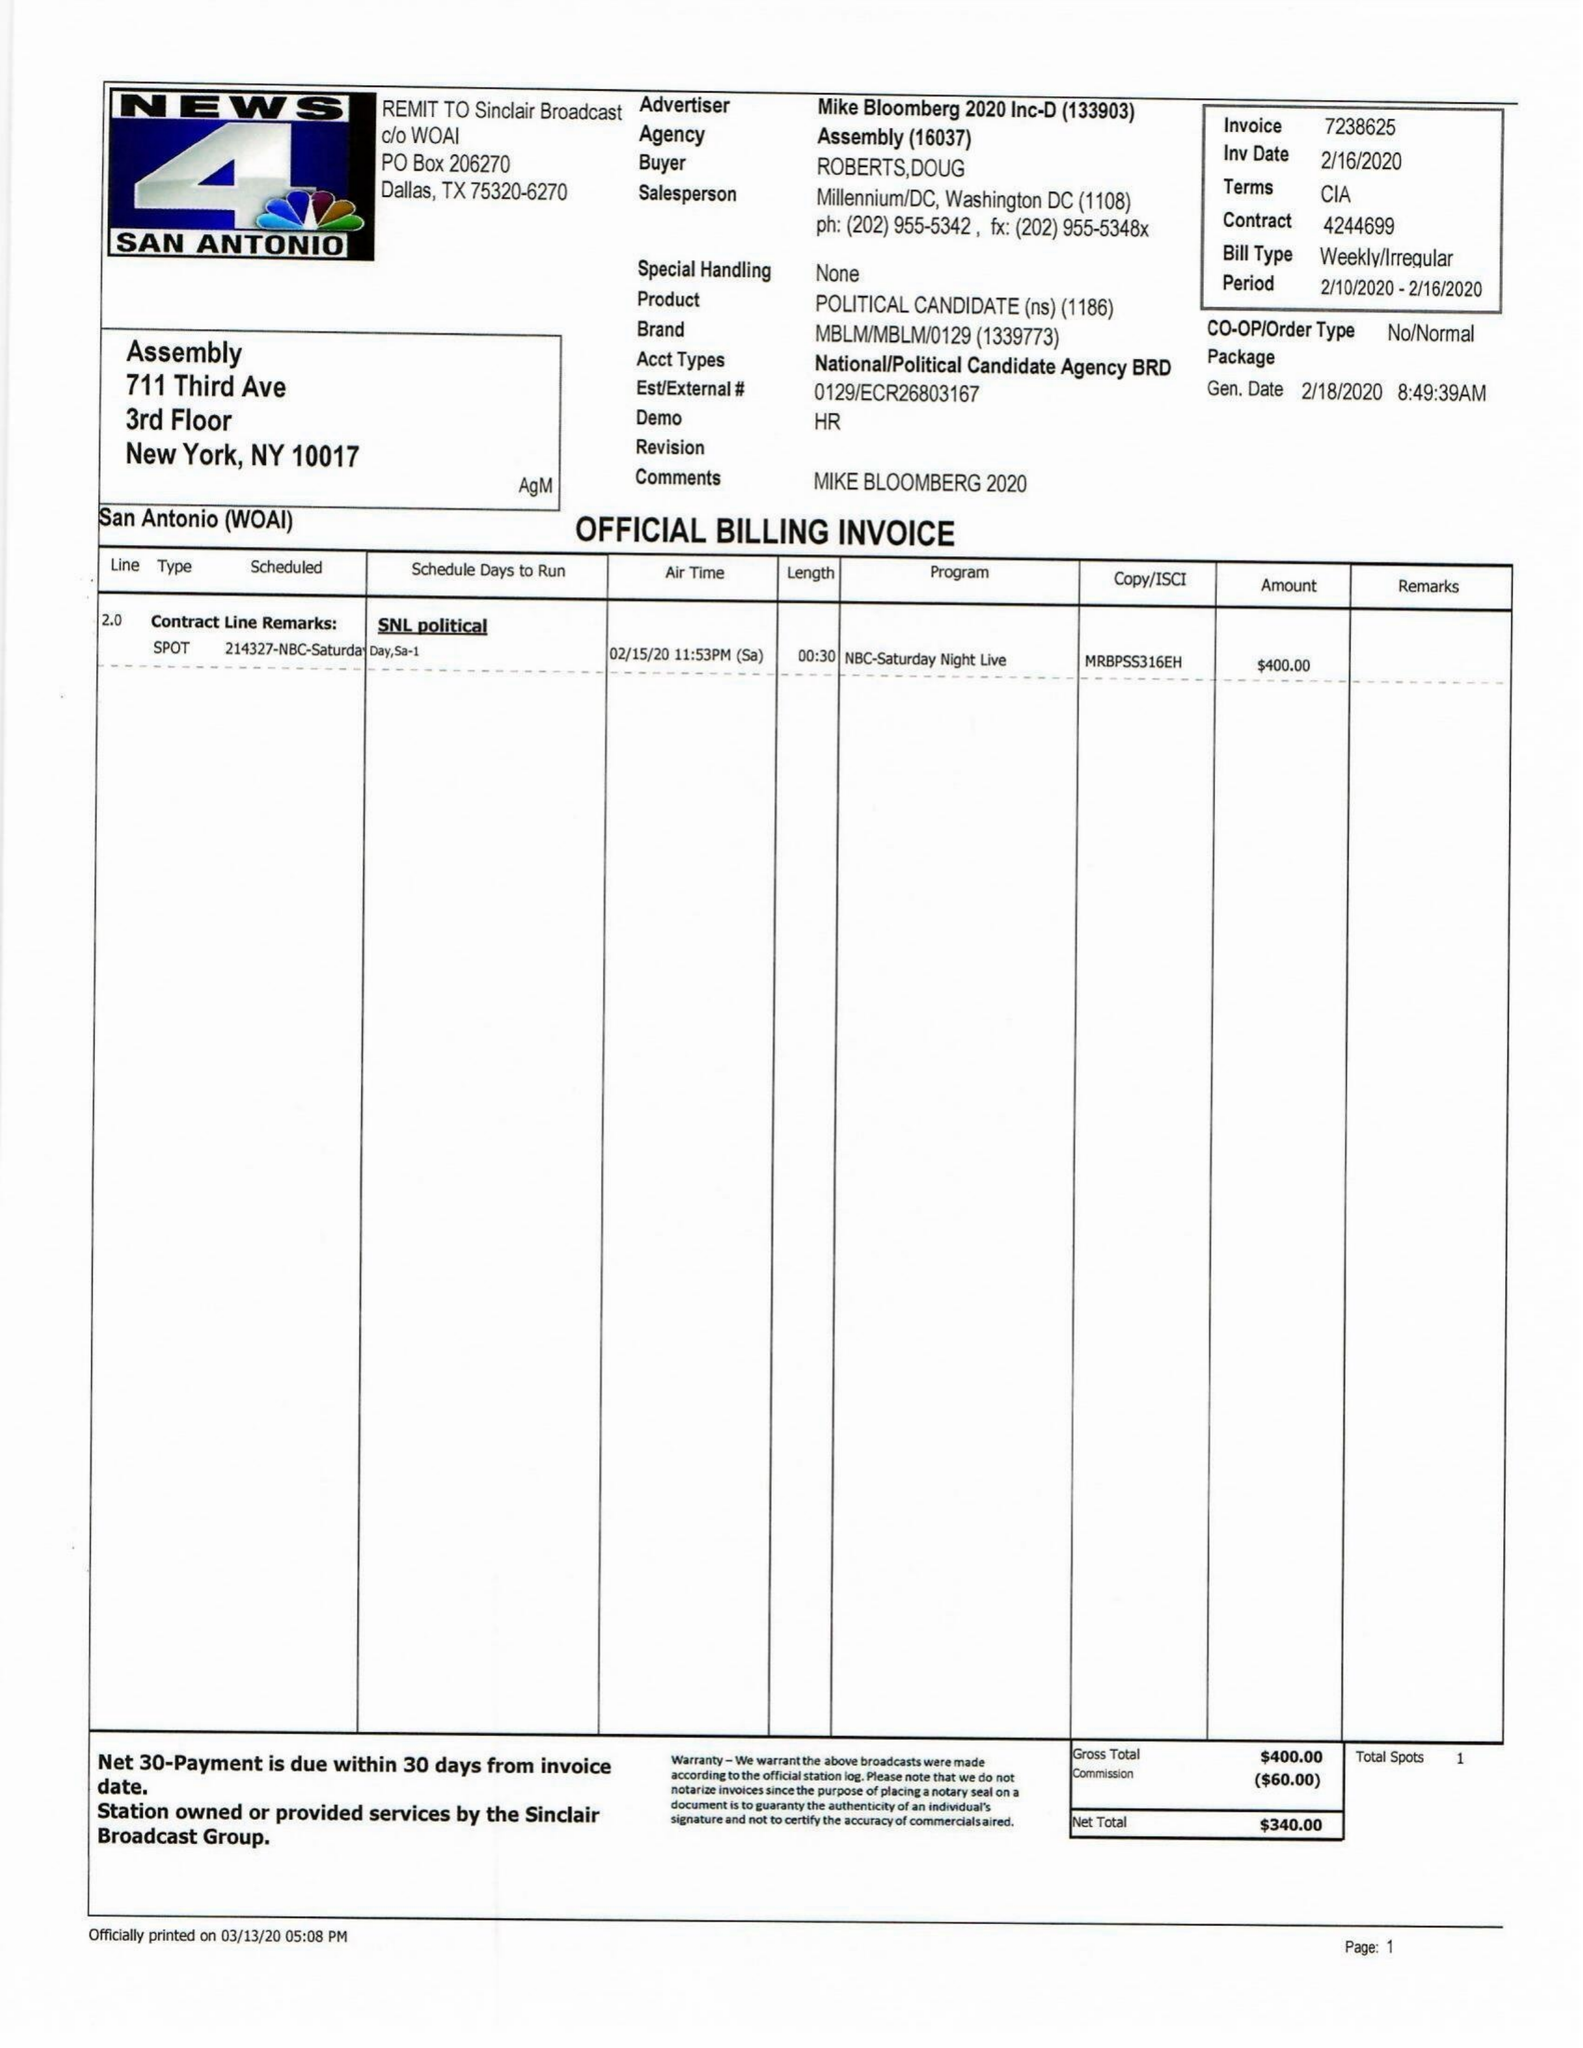What is the value for the flight_to?
Answer the question using a single word or phrase. 02/16/20 